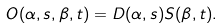<formula> <loc_0><loc_0><loc_500><loc_500>O ( \alpha , s , \beta , t ) = D ( \alpha , s ) S ( \beta , t ) .</formula> 